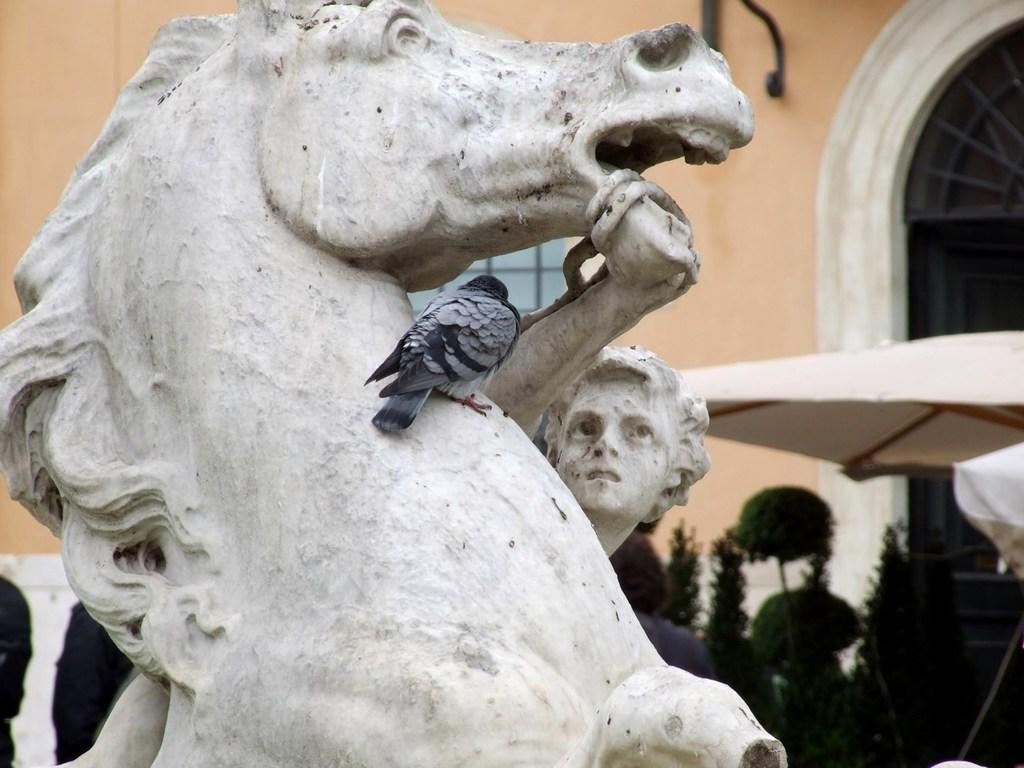What is on the statue in the image? There is a bird on a statue in the image. What type of structure is visible in the image? There is a building with windows in the image. What is on top of the building? The building has a roof in the image. What type of vegetation is near the building? There are plants near the building in the image. Who or what else can be seen in the image? There is a person visible in the image. What type of secretary can be seen working near the mailbox in the image? There is no secretary or mailbox present in the image. What color is the needle used by the person in the image? There is no needle or person performing a task with a needle in the image. 